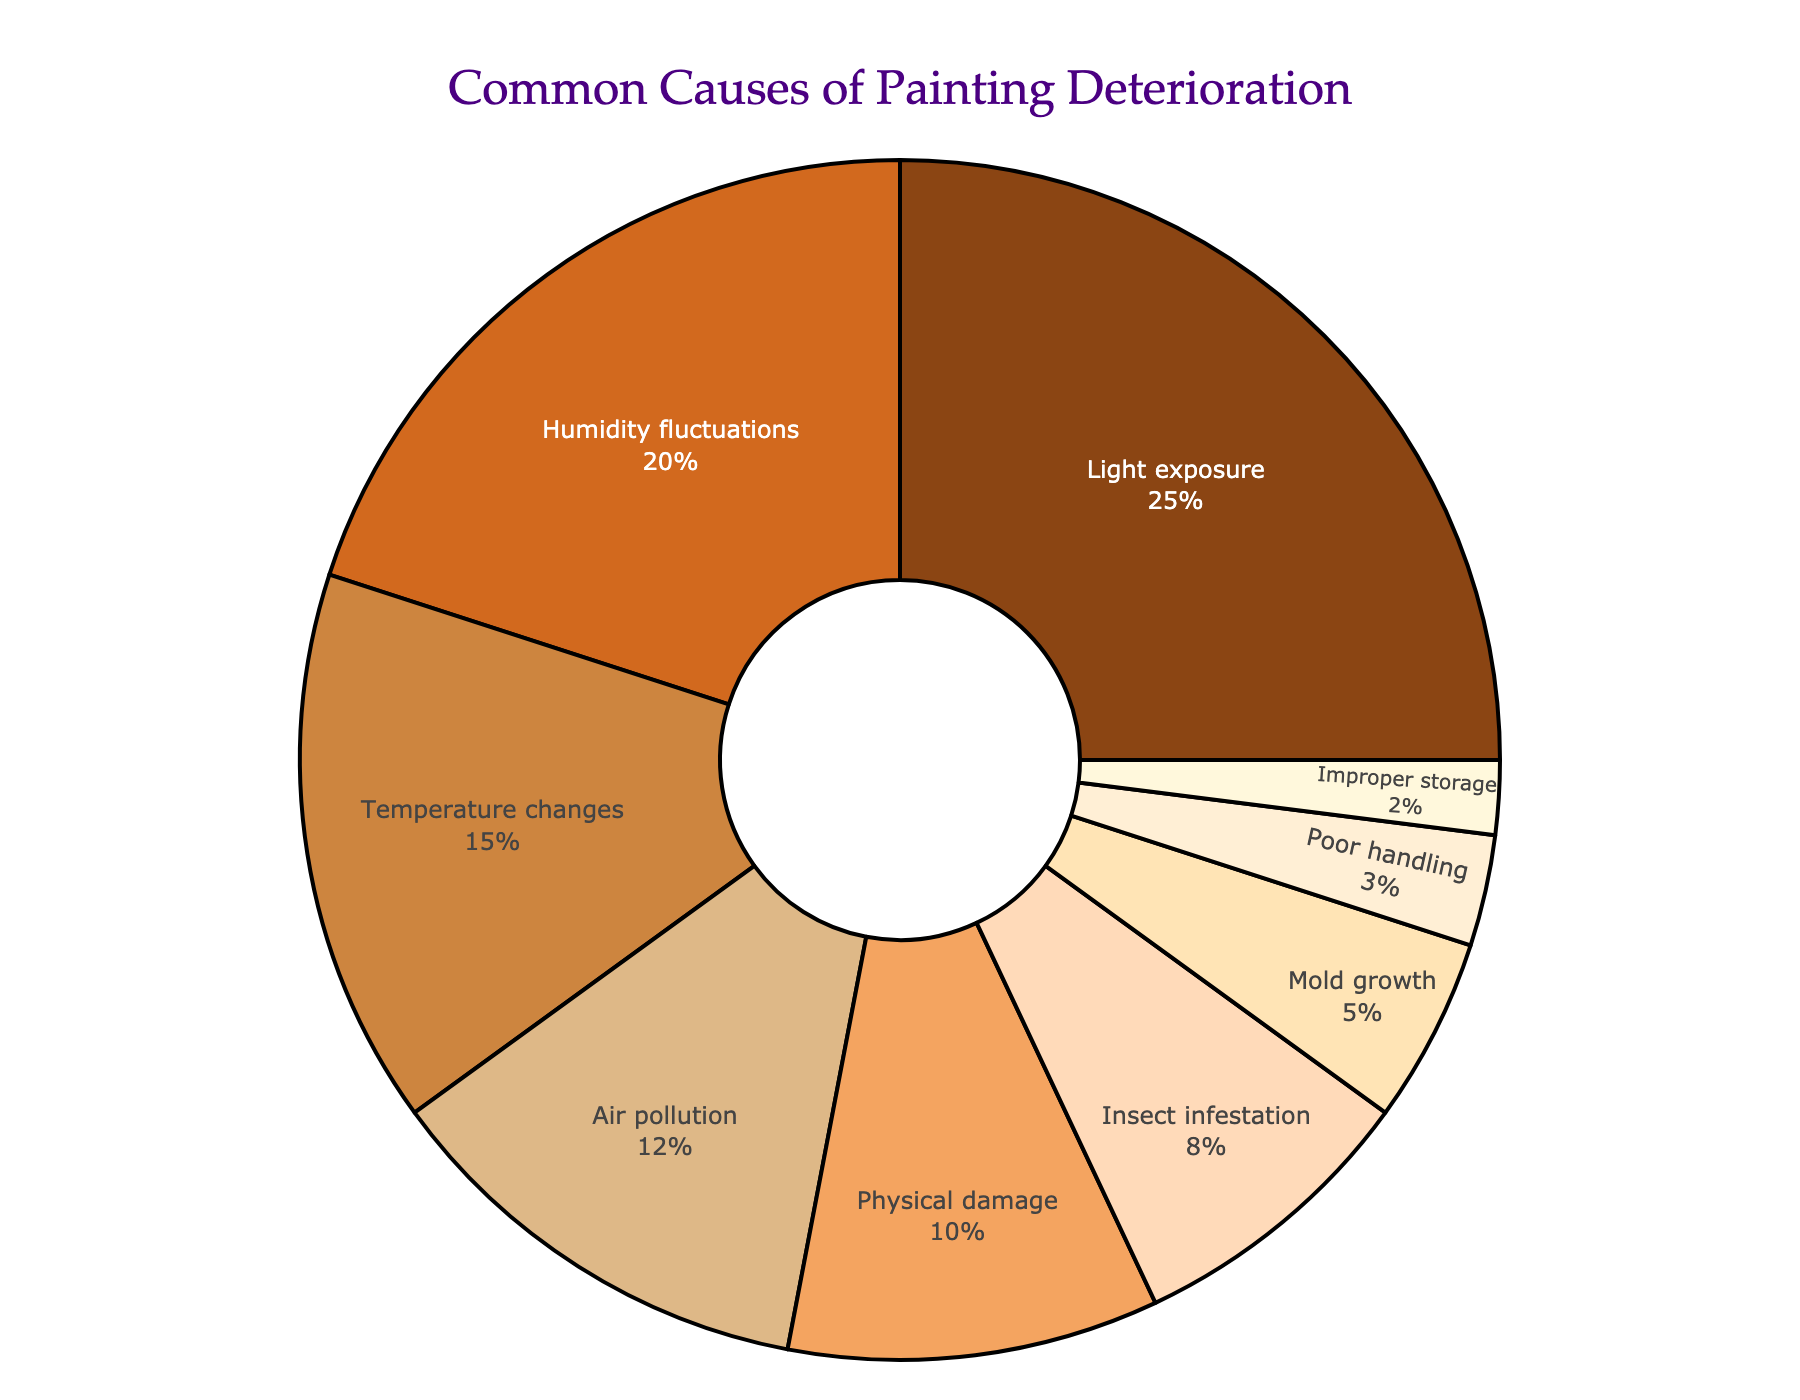What's the largest single cause of painting deterioration represented in the pie chart? The largest cause of painting deterioration is represented by the largest segment of the pie chart. From the figure, Light exposure is the largest segment with 25%.
Answer: Light exposure How much percentage more does Light exposure contribute to painting deterioration compared to Mold growth? To find how much more Light exposure contributes than Mold growth, subtract Mold growth's percentage from Light exposure's percentage (25% - 5%).
Answer: 20% What is the sum percentage of deterioration causes related to environmental factors such as Light exposure, Humidity fluctuations, and Temperature changes? Add the percentages of Light exposure (25%), Humidity fluctuations (20%), and Temperature changes (15%). The sum is 25% + 20% + 15% = 60%.
Answer: 60% Which has a smaller contribution to painting deterioration: Air pollution or Physical damage? Compare the percentages of Air pollution (12%) and Physical damage (10%). Physical damage's contribution is smaller.
Answer: Physical damage Rank the top three causes of painting deterioration in order of their contribution. Identify the top three largest segments and order them. They are Light exposure (25%), Humidity fluctuations (20%), and Temperature changes (15%).
Answer: 1. Light exposure, 2. Humidity fluctuations, 3. Temperature changes What percentage of painting deterioration is caused by Insect infestation and Improper storage combined? Add the percentages of Insect infestation (8%) and Improper storage (2%). The combined percentage is 8% + 2% = 10%.
Answer: 10% Which cause of deterioration has the second lowest percentage, and what is that percentage? Identify the cause that has the second smallest segment. Poor handling is the second smallest with 3%.
Answer: Poor handling, 3% By how much does Air pollution's percentage exceed Mold growth's percentage? Substract Mold growth's percentage (5%) from Air pollution's percentage (12%). The difference is 12% - 5% = 7%.
Answer: 7% If we were to create a consolidated category named "Environmental factors" that sums up Light exposure, Humidity fluctuations, Temperature changes, and Air pollution, what would its total percentage be? Add the percentages of the four causes: Light exposure (25%), Humidity fluctuations (20%), Temperature changes (15%), and Air pollution (12%). The total is 25% + 20% + 15% + 12% = 72%.
Answer: 72% What causes collectively form less than 10% each of painting deterioration? Identify the causes whose percentages are less than 10%: Physical damage (10%), Insect infestation (8%), Mold growth (5%), Poor handling (3%), Improper storage (2%). Physical damage is excluded as it exactly equals 10%.
Answer: Insect infestation, Mold growth, Poor handling, Improper storage 